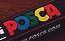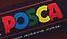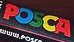What text is displayed in these images sequentially, separated by a semicolon? POSCA; POSCA; POSCA 